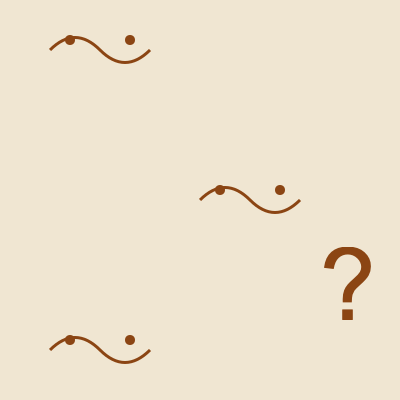Based on the given fragments of an Aboriginal rock painting, determine the correct orientation of the complete artwork. Which direction should the curved lines with circular elements be facing? To determine the correct orientation of the Aboriginal rock painting, we need to analyze the fragments and consider the typical characteristics of Aboriginal rock art:

1. Aboriginal rock paintings often depict natural elements, animals, or spiritual beings.
2. The curved lines with circular elements likely represent a stylized figure or creature.
3. In Aboriginal art, figures are usually oriented upright or horizontally.

Analyzing the fragments:
1. Fragment 1 (top left): Curved line with two circles above it.
2. Fragment 2 (middle right): Similar curved line with two circles above it.
3. Fragment 3 (bottom left): Curved line with two circles above it, identical to Fragment 1.

Considering the repetition and consistency of the pattern, we can deduce:
1. The curved lines likely represent the body of a figure or creature.
2. The circular elements above the curves could represent eyes or other features.
3. The repetition suggests a series of similar figures arranged in a pattern.

Given this analysis, the most logical orientation would have the curved lines facing downward, with the circular elements above them. This orientation resembles a common depiction of figures or creatures in Aboriginal rock art, where the body is represented by a curved line and the head or facial features are simplified to circular shapes.

Therefore, the correct orientation of the complete artwork would have the curved lines facing downward.
Answer: Downward 